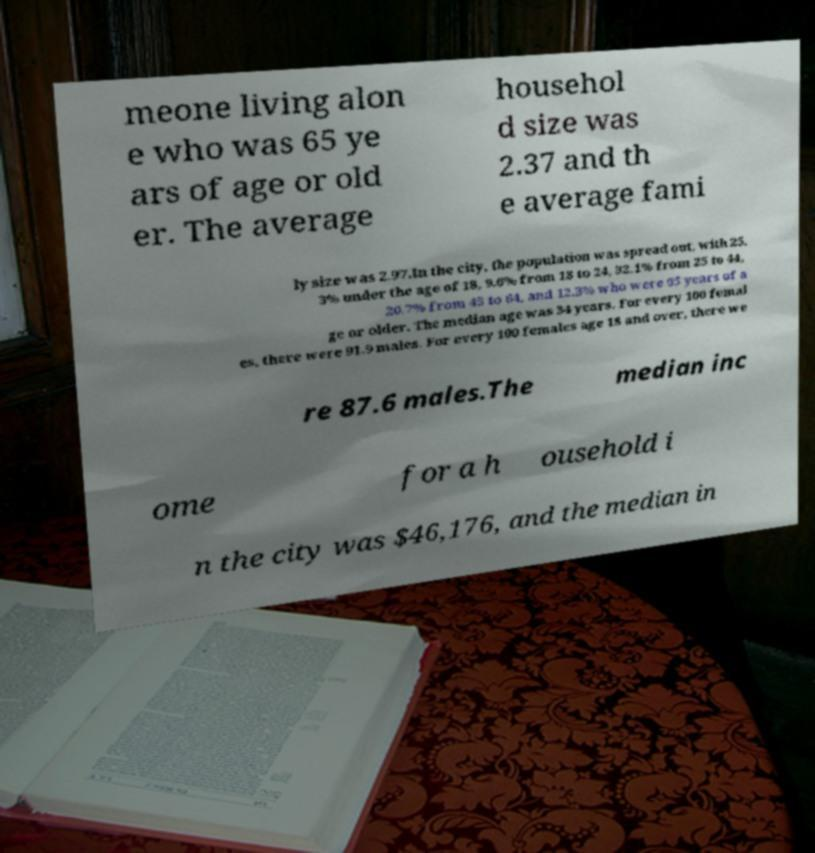Can you accurately transcribe the text from the provided image for me? meone living alon e who was 65 ye ars of age or old er. The average househol d size was 2.37 and th e average fami ly size was 2.97.In the city, the population was spread out, with 25. 3% under the age of 18, 9.6% from 18 to 24, 32.1% from 25 to 44, 20.7% from 45 to 64, and 12.3% who were 65 years of a ge or older. The median age was 34 years. For every 100 femal es, there were 91.9 males. For every 100 females age 18 and over, there we re 87.6 males.The median inc ome for a h ousehold i n the city was $46,176, and the median in 